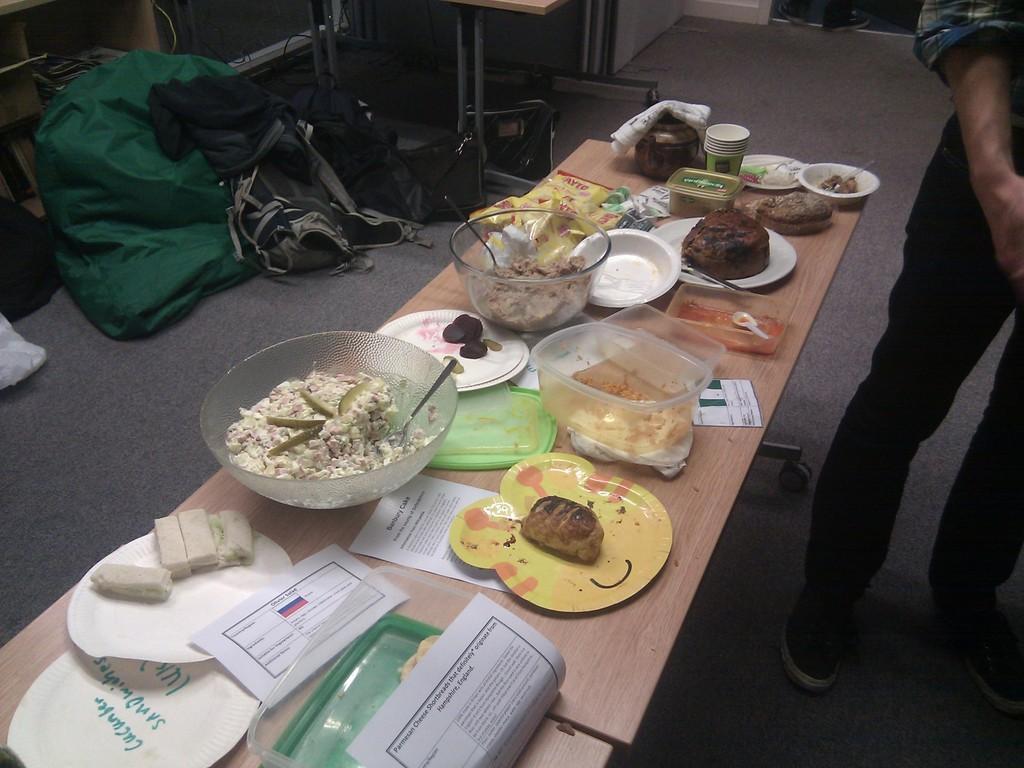Please provide a concise description of this image. In the center of the image we can see a table. On the table there are bowls, food, meat, spoons, glasses and paper. On the right side of the image there is a person. On the left side we can see bags and tables. 